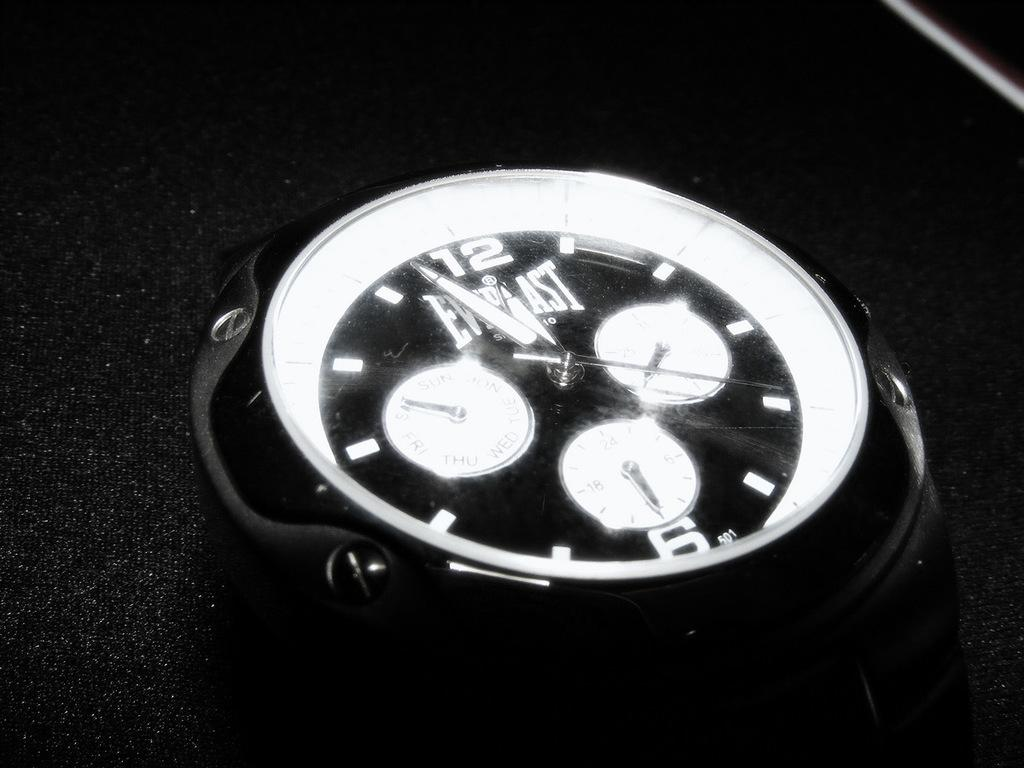Provide a one-sentence caption for the provided image. An Everlast clock has white dials and a black background. 